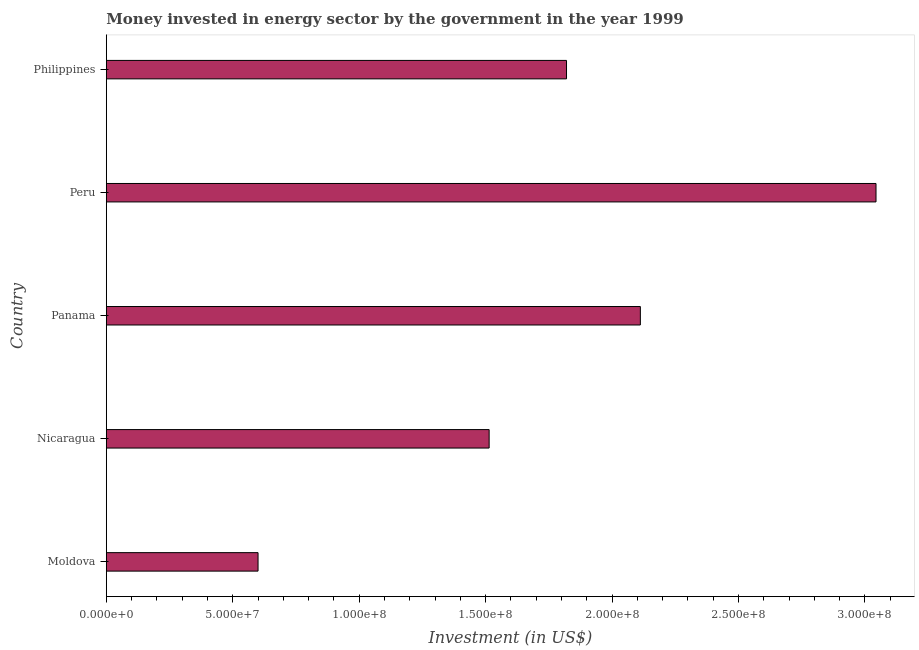Does the graph contain grids?
Your answer should be compact. No. What is the title of the graph?
Make the answer very short. Money invested in energy sector by the government in the year 1999. What is the label or title of the X-axis?
Your answer should be compact. Investment (in US$). What is the label or title of the Y-axis?
Make the answer very short. Country. What is the investment in energy in Nicaragua?
Make the answer very short. 1.51e+08. Across all countries, what is the maximum investment in energy?
Provide a short and direct response. 3.04e+08. Across all countries, what is the minimum investment in energy?
Your answer should be very brief. 6.00e+07. In which country was the investment in energy maximum?
Give a very brief answer. Peru. In which country was the investment in energy minimum?
Your answer should be very brief. Moldova. What is the sum of the investment in energy?
Keep it short and to the point. 9.09e+08. What is the difference between the investment in energy in Nicaragua and Philippines?
Keep it short and to the point. -3.06e+07. What is the average investment in energy per country?
Keep it short and to the point. 1.82e+08. What is the median investment in energy?
Offer a very short reply. 1.82e+08. In how many countries, is the investment in energy greater than 200000000 US$?
Provide a succinct answer. 2. What is the ratio of the investment in energy in Nicaragua to that in Philippines?
Provide a short and direct response. 0.83. What is the difference between the highest and the second highest investment in energy?
Give a very brief answer. 9.32e+07. What is the difference between the highest and the lowest investment in energy?
Your answer should be compact. 2.44e+08. How many bars are there?
Provide a succinct answer. 5. What is the Investment (in US$) of Moldova?
Your answer should be compact. 6.00e+07. What is the Investment (in US$) of Nicaragua?
Offer a very short reply. 1.51e+08. What is the Investment (in US$) of Panama?
Give a very brief answer. 2.11e+08. What is the Investment (in US$) of Peru?
Your answer should be very brief. 3.04e+08. What is the Investment (in US$) of Philippines?
Your answer should be very brief. 1.82e+08. What is the difference between the Investment (in US$) in Moldova and Nicaragua?
Give a very brief answer. -9.14e+07. What is the difference between the Investment (in US$) in Moldova and Panama?
Give a very brief answer. -1.51e+08. What is the difference between the Investment (in US$) in Moldova and Peru?
Give a very brief answer. -2.44e+08. What is the difference between the Investment (in US$) in Moldova and Philippines?
Keep it short and to the point. -1.22e+08. What is the difference between the Investment (in US$) in Nicaragua and Panama?
Give a very brief answer. -5.98e+07. What is the difference between the Investment (in US$) in Nicaragua and Peru?
Your response must be concise. -1.53e+08. What is the difference between the Investment (in US$) in Nicaragua and Philippines?
Ensure brevity in your answer.  -3.06e+07. What is the difference between the Investment (in US$) in Panama and Peru?
Your response must be concise. -9.32e+07. What is the difference between the Investment (in US$) in Panama and Philippines?
Provide a short and direct response. 2.92e+07. What is the difference between the Investment (in US$) in Peru and Philippines?
Your response must be concise. 1.22e+08. What is the ratio of the Investment (in US$) in Moldova to that in Nicaragua?
Your response must be concise. 0.4. What is the ratio of the Investment (in US$) in Moldova to that in Panama?
Offer a very short reply. 0.28. What is the ratio of the Investment (in US$) in Moldova to that in Peru?
Make the answer very short. 0.2. What is the ratio of the Investment (in US$) in Moldova to that in Philippines?
Provide a short and direct response. 0.33. What is the ratio of the Investment (in US$) in Nicaragua to that in Panama?
Your answer should be very brief. 0.72. What is the ratio of the Investment (in US$) in Nicaragua to that in Peru?
Give a very brief answer. 0.5. What is the ratio of the Investment (in US$) in Nicaragua to that in Philippines?
Give a very brief answer. 0.83. What is the ratio of the Investment (in US$) in Panama to that in Peru?
Your answer should be compact. 0.69. What is the ratio of the Investment (in US$) in Panama to that in Philippines?
Give a very brief answer. 1.16. What is the ratio of the Investment (in US$) in Peru to that in Philippines?
Keep it short and to the point. 1.67. 